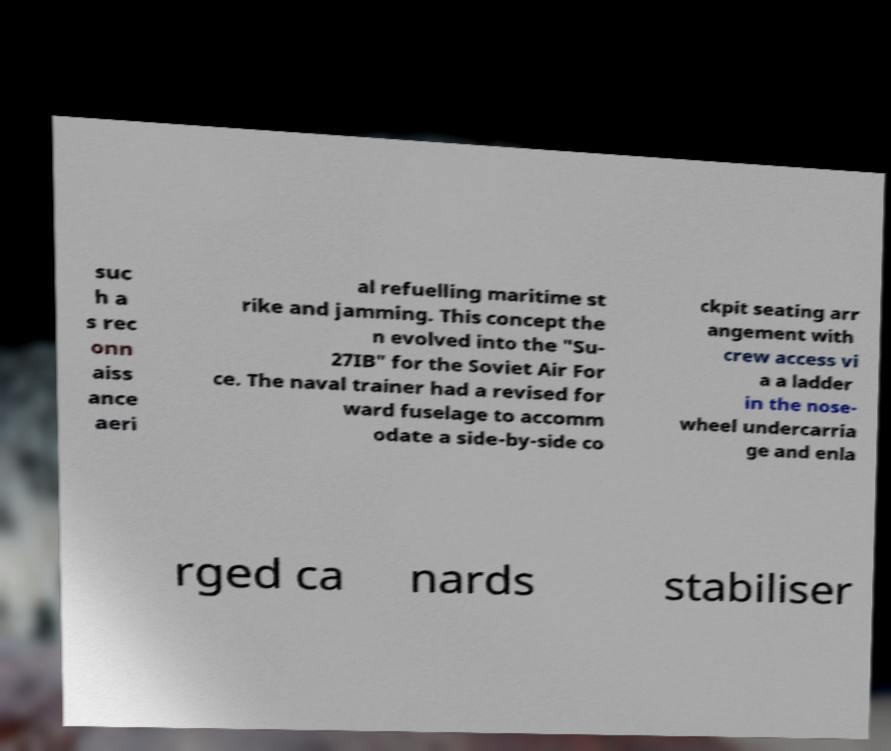Could you extract and type out the text from this image? suc h a s rec onn aiss ance aeri al refuelling maritime st rike and jamming. This concept the n evolved into the "Su- 27IB" for the Soviet Air For ce. The naval trainer had a revised for ward fuselage to accomm odate a side-by-side co ckpit seating arr angement with crew access vi a a ladder in the nose- wheel undercarria ge and enla rged ca nards stabiliser 